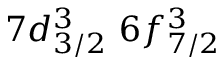<formula> <loc_0><loc_0><loc_500><loc_500>7 d _ { 3 / 2 } ^ { 3 } \, 6 f _ { 7 / 2 } ^ { 3 } \,</formula> 